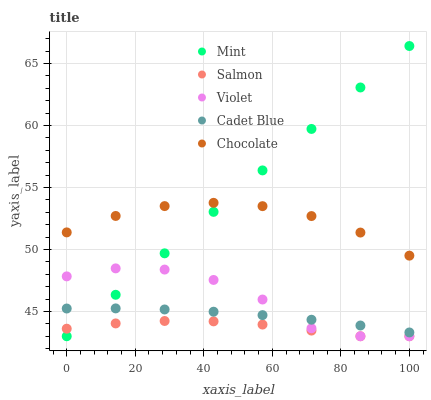Does Salmon have the minimum area under the curve?
Answer yes or no. Yes. Does Mint have the maximum area under the curve?
Answer yes or no. Yes. Does Cadet Blue have the minimum area under the curve?
Answer yes or no. No. Does Cadet Blue have the maximum area under the curve?
Answer yes or no. No. Is Mint the smoothest?
Answer yes or no. Yes. Is Violet the roughest?
Answer yes or no. Yes. Is Salmon the smoothest?
Answer yes or no. No. Is Salmon the roughest?
Answer yes or no. No. Does Salmon have the lowest value?
Answer yes or no. Yes. Does Cadet Blue have the lowest value?
Answer yes or no. No. Does Mint have the highest value?
Answer yes or no. Yes. Does Cadet Blue have the highest value?
Answer yes or no. No. Is Violet less than Chocolate?
Answer yes or no. Yes. Is Cadet Blue greater than Salmon?
Answer yes or no. Yes. Does Mint intersect Salmon?
Answer yes or no. Yes. Is Mint less than Salmon?
Answer yes or no. No. Is Mint greater than Salmon?
Answer yes or no. No. Does Violet intersect Chocolate?
Answer yes or no. No. 